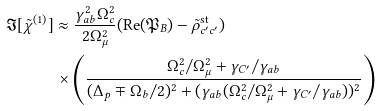Convert formula to latex. <formula><loc_0><loc_0><loc_500><loc_500>\Im [ \tilde { \chi } ^ { ( 1 ) } ] & \approx \frac { \gamma _ { a b } ^ { 2 } \Omega _ { c } ^ { 2 } } { 2 \Omega _ { \mu } ^ { 2 } } ( \text {Re} ( \mathfrak { P } _ { B } ) - \tilde { \rho } _ { c ^ { \prime } c ^ { \prime } } ^ { \text {st} } ) \\ & \, \times \left ( \frac { \Omega _ { c } ^ { 2 } / \Omega _ { \mu } ^ { 2 } + \gamma _ { C ^ { \prime } } / \gamma _ { a b } } { ( \Delta _ { p } \mp \Omega _ { b } / 2 ) ^ { 2 } + ( \gamma _ { a b } ( \Omega _ { c } ^ { 2 } / \Omega _ { \mu } ^ { 2 } + \gamma _ { C ^ { \prime } } / \gamma _ { a b } ) ) ^ { 2 } } \right )</formula> 